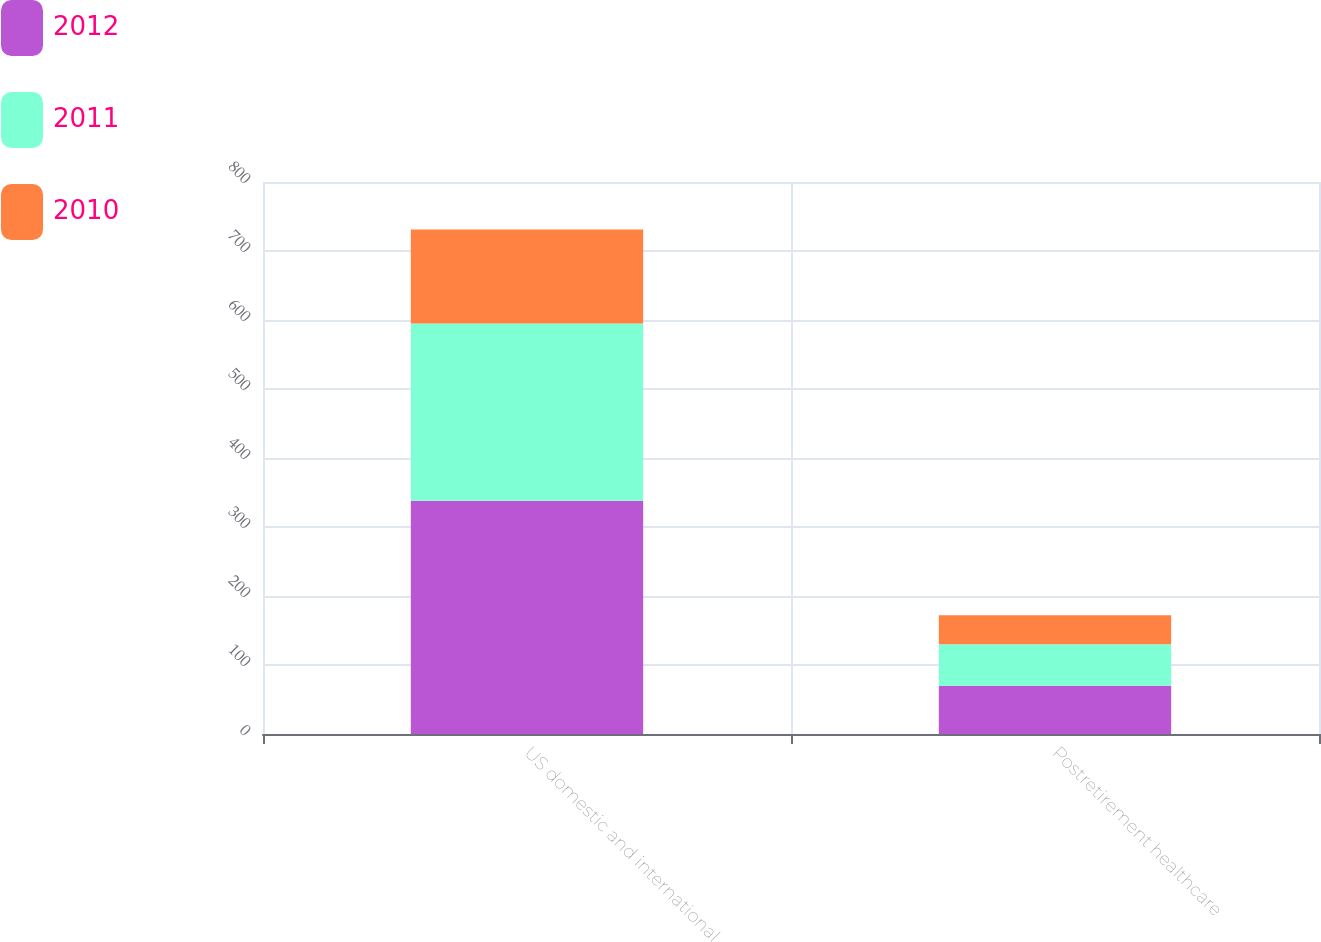Convert chart. <chart><loc_0><loc_0><loc_500><loc_500><stacked_bar_chart><ecel><fcel>US domestic and international<fcel>Postretirement healthcare<nl><fcel>2012<fcel>338<fcel>70<nl><fcel>2011<fcel>257<fcel>60<nl><fcel>2010<fcel>136<fcel>42<nl></chart> 